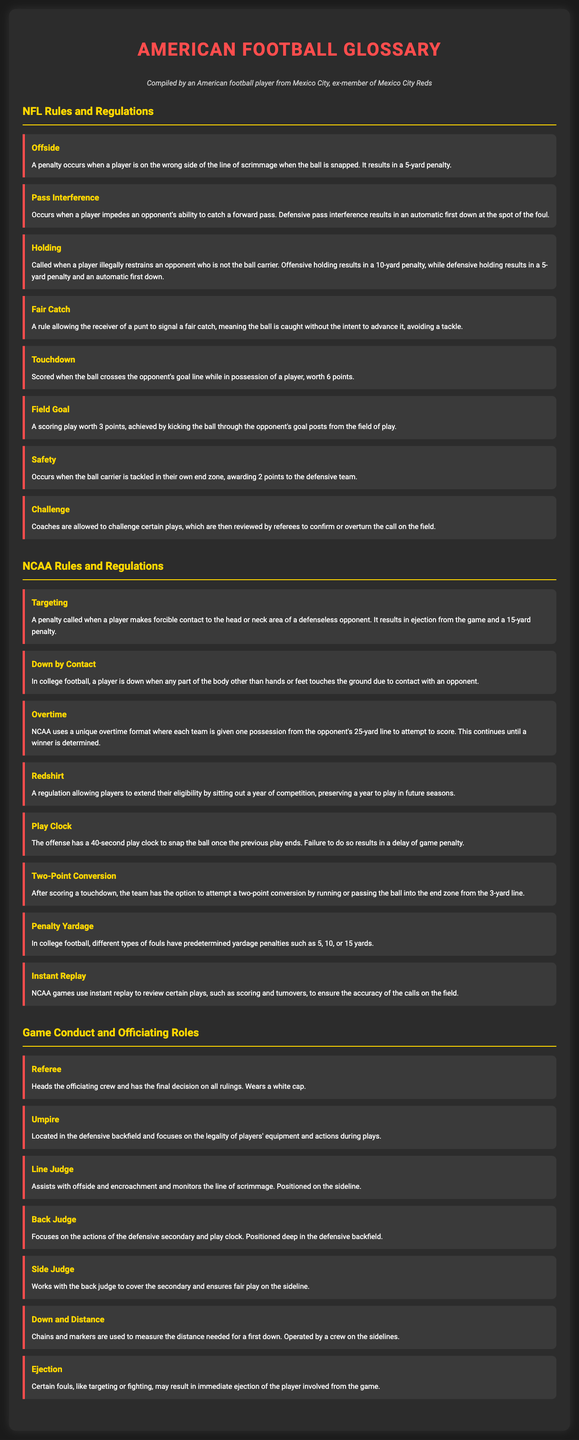What is a penalty for offside? The term describes a penalty that occurs when a player is on the wrong side of the line of scrimmage when the ball is snapped, resulting in a 5-yard penalty.
Answer: 5-yard penalty What happens in pass interference? The definition explains that it occurs when a player impedes an opponent's ability to catch a forward pass, resulting in an automatic first down at the spot of the foul.
Answer: Automatic first down What is the value of a touchdown? The document states that a touchdown is scored when the ball crosses the opponent's goal line while in possession of a player, worth 6 points.
Answer: 6 points What is targeting in NCAA? The term describes a penalty called when a player makes forcible contact to the head or neck area of a defenseless opponent, which leads to ejection and a 15-yard penalty.
Answer: Ejection and 15-yard penalty What happens during overtime in NCAA? The rule explains that NCAA uses a unique format where each team gets one possession from the opponent's 25-yard line to attempt to score, continuing until a winner is determined.
Answer: One possession from the opponent's 25-yard line Who heads the officiating crew? The document specifies that the referee heads the officiating crew and has the final decision on all rulings, wearing a white cap.
Answer: Referee What is the role of the umpire? The definition indicates that the umpire is located in the defensive backfield and focuses on the legality of players' equipment and actions during plays.
Answer: Legality of players' equipment What can result in ejection from the game? The document mentions that certain fouls, like targeting or fighting, may result in immediate ejection of the player involved from the game.
Answer: Targeting or fighting 